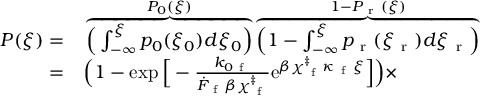<formula> <loc_0><loc_0><loc_500><loc_500>\begin{array} { r l } { P ( \xi ) = } & \overbrace { \left ( \int _ { - \infty } ^ { \xi } p _ { 0 } ( \xi _ { 0 } ) d \xi _ { 0 } \right ) } ^ { P _ { 0 } ( \xi ) } \overbrace { \left ( 1 - \int _ { - \infty } ^ { \xi } p _ { r } ( \xi _ { r } ) d \xi _ { r } \right ) } ^ { 1 - P _ { r } ( \xi ) } } \\ { = } & \left ( 1 - \exp \left [ - \frac { k _ { 0 f } } { \dot { F } _ { f } \beta \chi _ { f } ^ { \ddag } } e ^ { \beta \chi _ { f } ^ { \ddag } \kappa _ { f } \xi } \right ] \right ) \times } \end{array}</formula> 